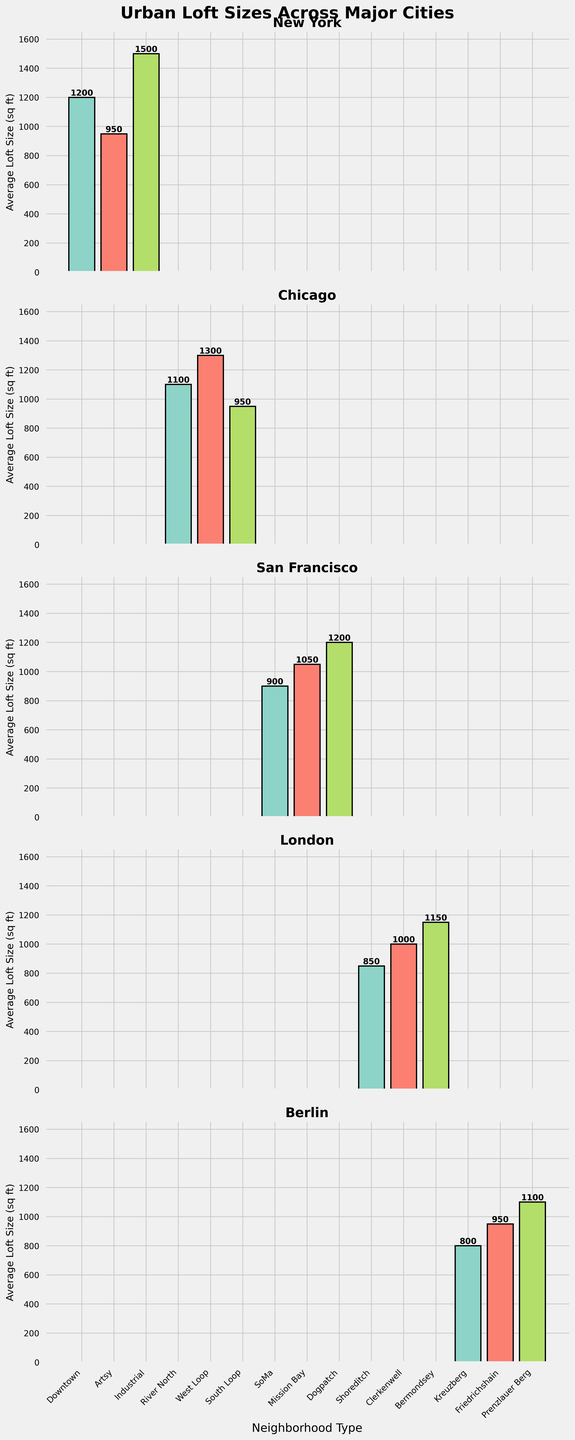What's the title of the figure? The title is displayed at the top of the figure. It reads "Urban Loft Sizes Across Major Cities".
Answer: Urban Loft Sizes Across Major Cities Which city has the highest average loft size? Look at all the subplots and identify the loft size for each neighborhood in each city. The highest value is from the Industrial neighborhood in New York with a size of 1500 sq ft.
Answer: New York What is the average loft size in San Francisco's Dogpatch neighborhood? Locate the San Francisco subplot and find the bar corresponding to Dogpatch. The label on top of the bar says 1200 sq ft.
Answer: 1200 sq ft Which neighborhood type in Berlin has the smallest average loft size? Focus on the Berlin subplot and compare the heights of the bars. Kreuzberg has the smallest bar with an average loft size of 800 sq ft.
Answer: Kreuzberg How does the loft size in London's Shoreditch neighborhood compare to Clerkenwell? Look at the bars for Shoreditch and Clerkenwell in the London subplot. Shoreditch's bar is lower at 850 sq ft, whereas Clerkenwell's bar is higher at 1000 sq ft.
Answer: Shoreditch is smaller What is the range of loft sizes in Chicago? Look at the bars in the Chicago subplot and note the smallest and largest values. The smallest is South Loop with 950 sq ft, and the largest is West Loop with 1300 sq ft. The range is 1300 - 950 = 350 sq ft.
Answer: 350 sq ft Which city has the least variation in loft sizes across neighborhoods? Compare the range of loft sizes by looking at the height differences of bars within each subplot. Berlin shows the least variation with sizes ranging from 800 to 1100 sq ft.
Answer: Berlin What is the total loft size when combining the smallest loft sizes across all neighborhoods? Identify the smallest bar in each city: New York (Artsy 950), Chicago (South Loop 950), San Francisco (SoMa 900), London (Shoreditch 850), Berlin (Kreuzberg 800). Summing these values: 950 + 950 + 900 + 850 + 800 = 4450 sq ft.
Answer: 4450 sq ft What neighborhood type in New York has the second largest average loft size? Compare the bars in the New York subplot and sort them by height. The largest is Industrial (1500 sq ft), and the second largest is Downtown (1200 sq ft).
Answer: Downtown 